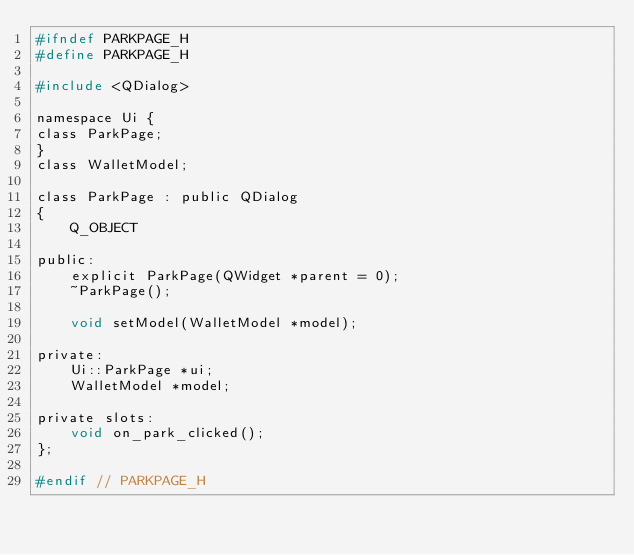Convert code to text. <code><loc_0><loc_0><loc_500><loc_500><_C_>#ifndef PARKPAGE_H
#define PARKPAGE_H

#include <QDialog>

namespace Ui {
class ParkPage;
}
class WalletModel;

class ParkPage : public QDialog
{
    Q_OBJECT

public:
    explicit ParkPage(QWidget *parent = 0);
    ~ParkPage();

    void setModel(WalletModel *model);

private:
    Ui::ParkPage *ui;
    WalletModel *model;

private slots:
    void on_park_clicked();
};

#endif // PARKPAGE_H
</code> 